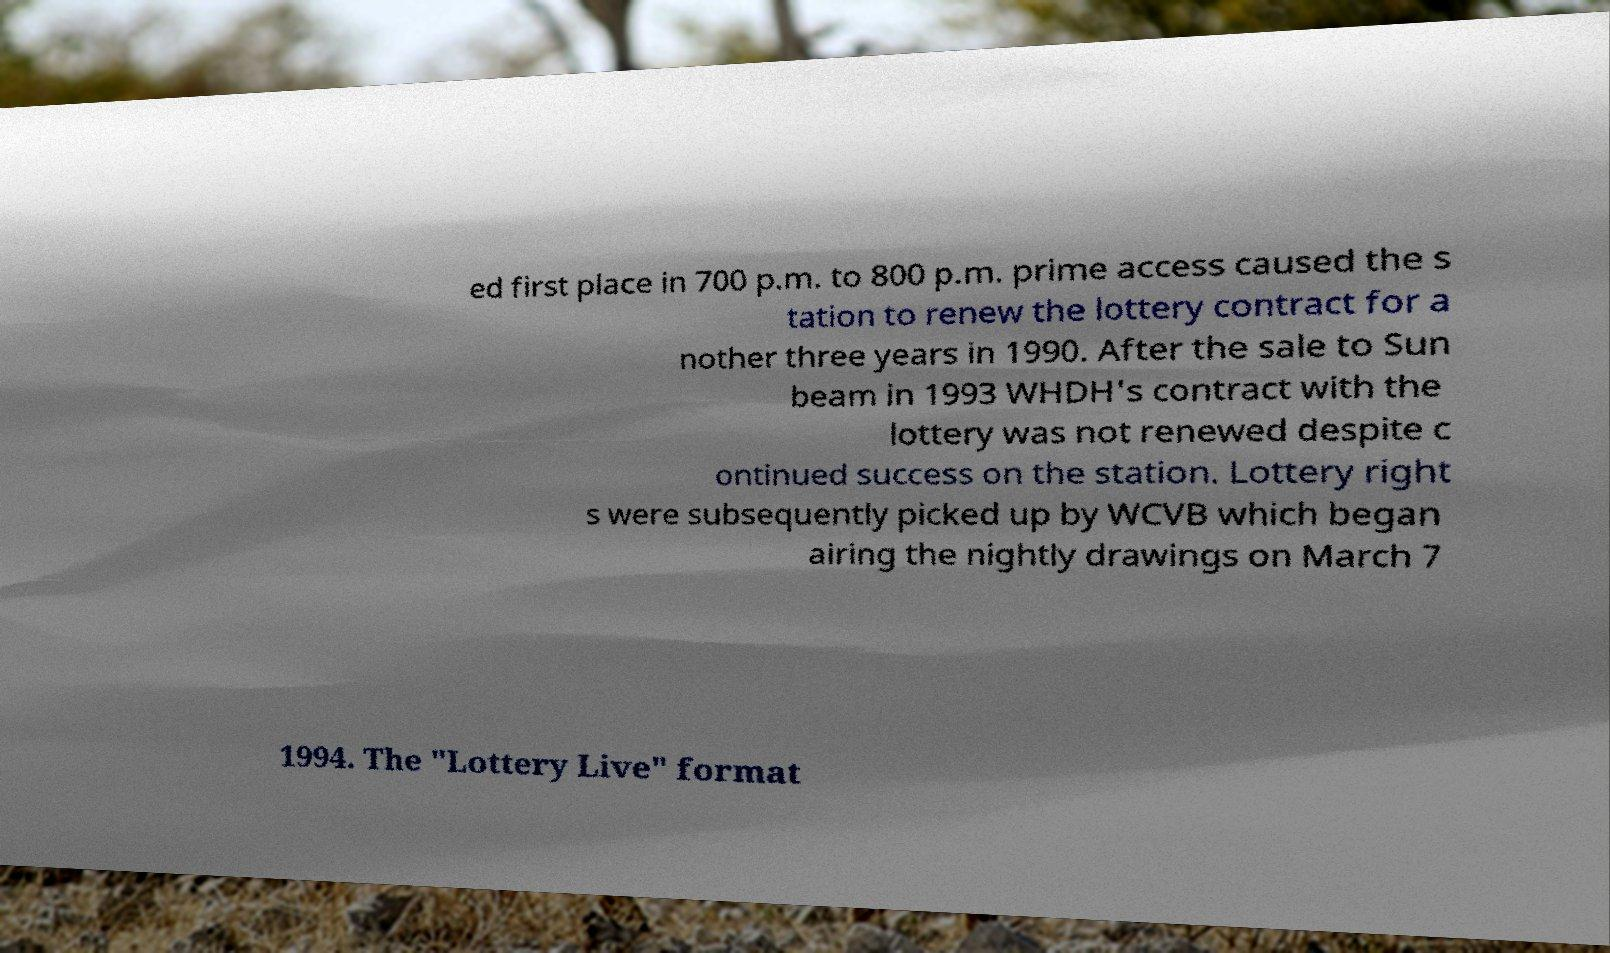Please read and relay the text visible in this image. What does it say? ed first place in 700 p.m. to 800 p.m. prime access caused the s tation to renew the lottery contract for a nother three years in 1990. After the sale to Sun beam in 1993 WHDH's contract with the lottery was not renewed despite c ontinued success on the station. Lottery right s were subsequently picked up by WCVB which began airing the nightly drawings on March 7 1994. The "Lottery Live" format 